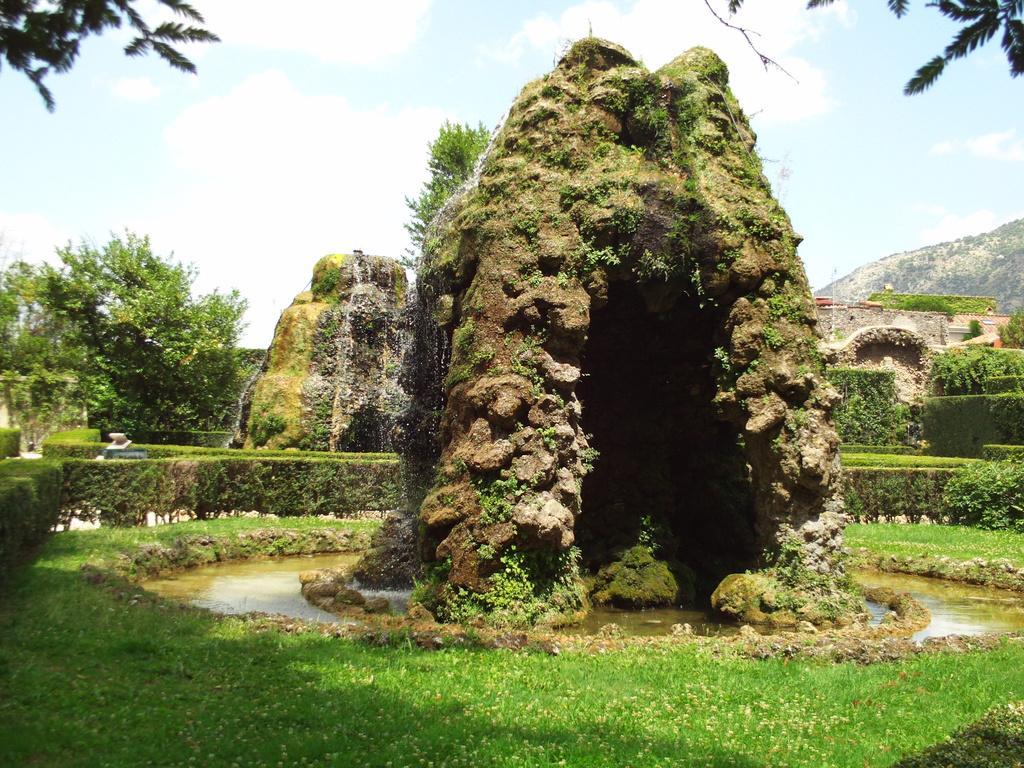In one or two sentences, can you explain what this image depicts? In this image there is a cave in middle of this image and there is a grassy land in the bottom of this image and there are some trees in the background. There is a sky on the top of this image. 